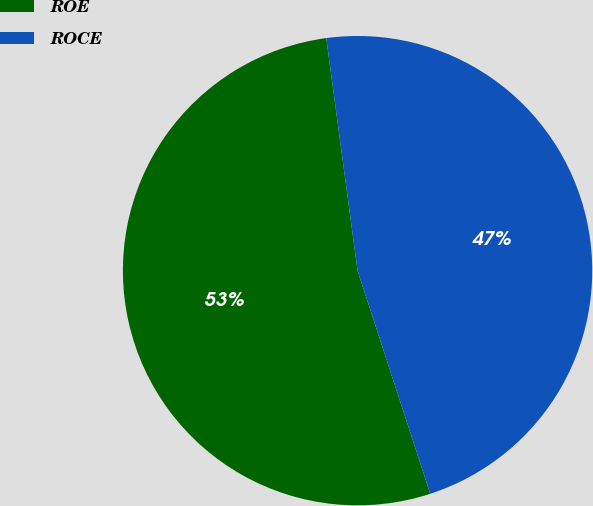Convert chart to OTSL. <chart><loc_0><loc_0><loc_500><loc_500><pie_chart><fcel>ROE<fcel>ROCE<nl><fcel>52.88%<fcel>47.12%<nl></chart> 